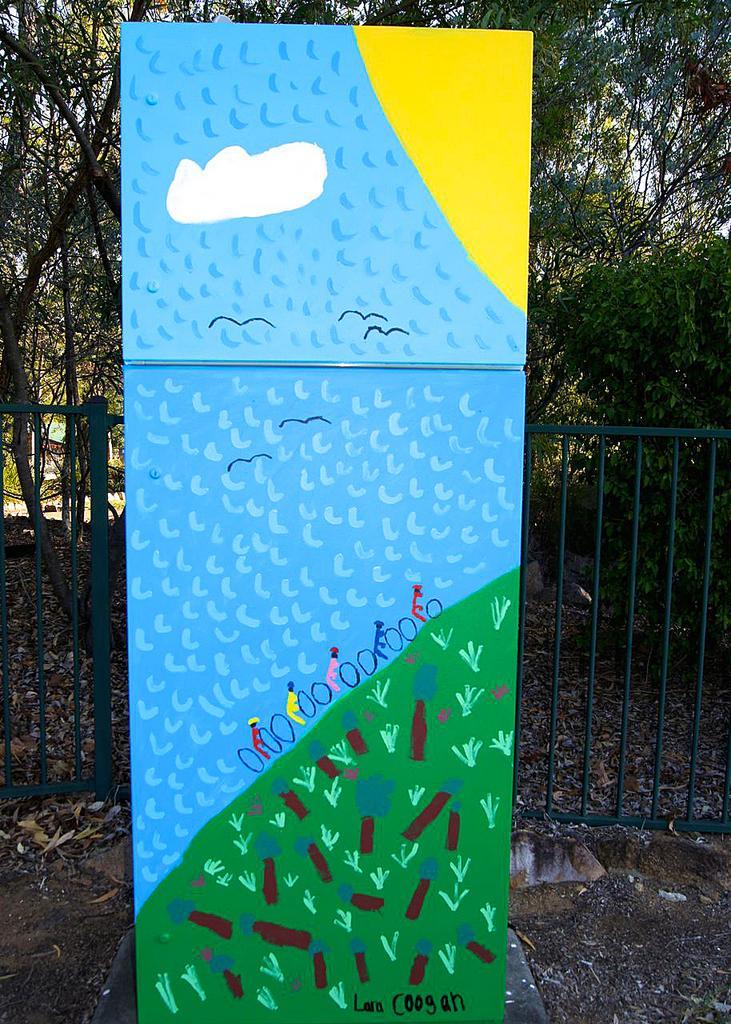Please provide a concise description of this image. In this image we can see many trees and plants. There is a painting on a board. We can see few persons, few birds, the sky, few other objects in the painting. 